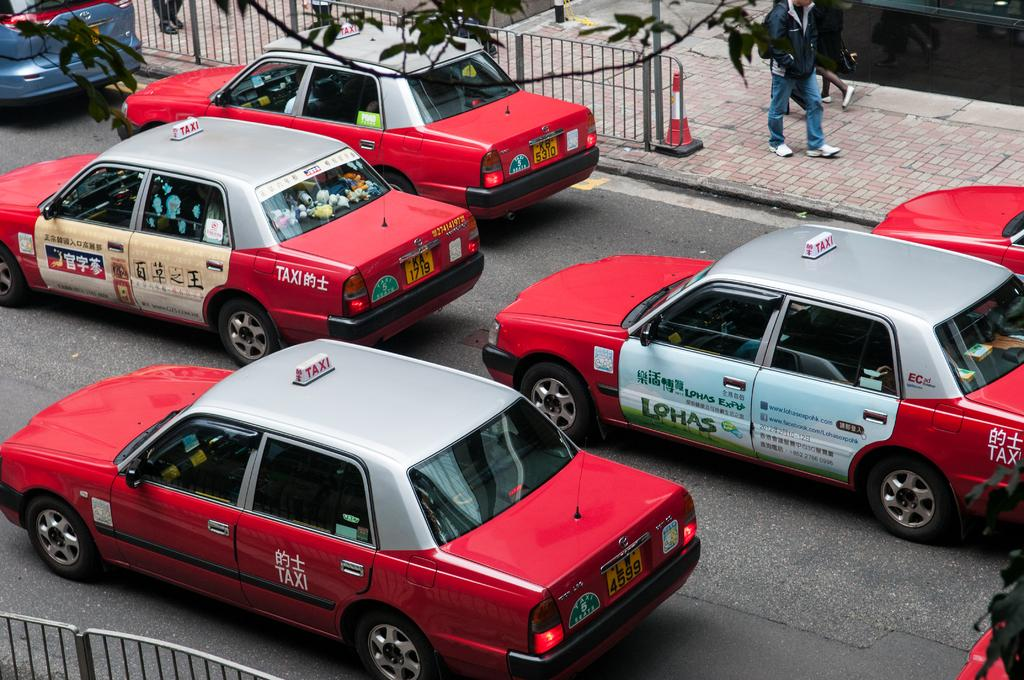<image>
Summarize the visual content of the image. a Lohas sign that is on the side of a car 